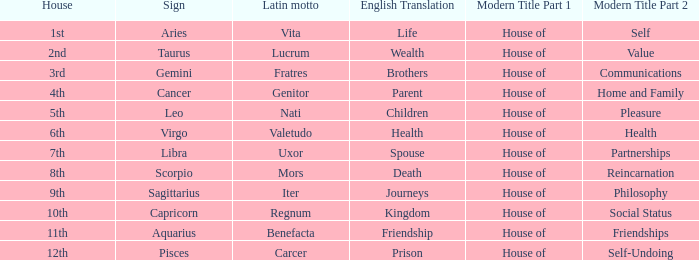What is the Latin motto of the sign that translates to spouse? Uxor. 